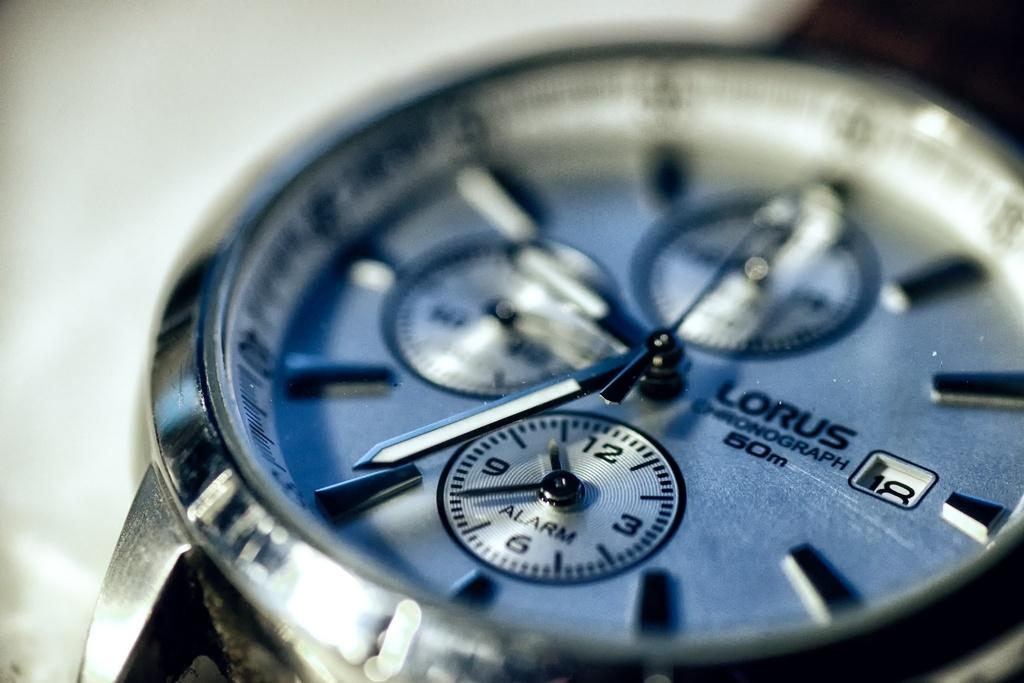Provide a one-sentence caption for the provided image. Baby blue face of a Lorus watch which has the time at 7. 